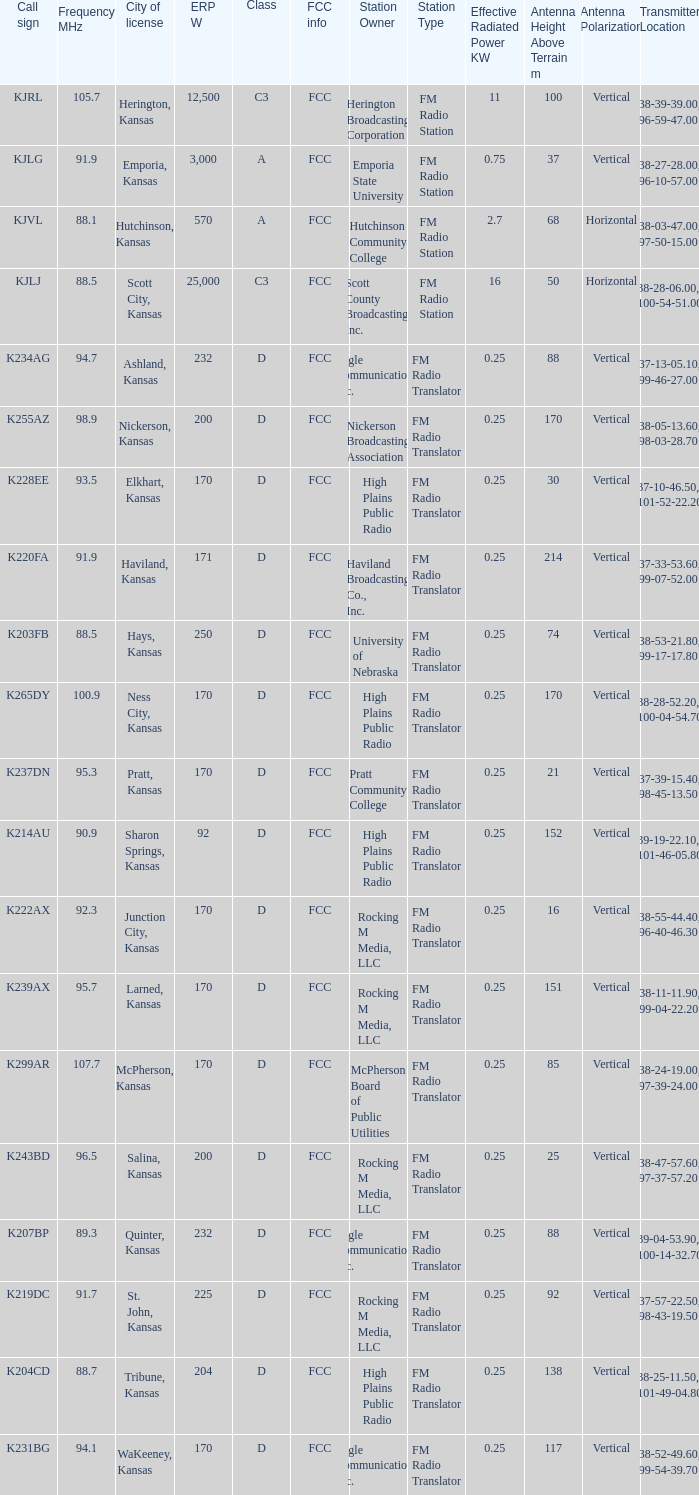Frequency MHz of 88.7 had what average erp w? 204.0. 